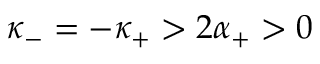Convert formula to latex. <formula><loc_0><loc_0><loc_500><loc_500>\kappa _ { - } = - \kappa _ { + } > 2 \alpha _ { + } > 0</formula> 